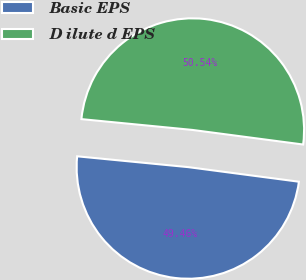Convert chart to OTSL. <chart><loc_0><loc_0><loc_500><loc_500><pie_chart><fcel>Basic EPS<fcel>D ilute d EPS<nl><fcel>49.46%<fcel>50.54%<nl></chart> 